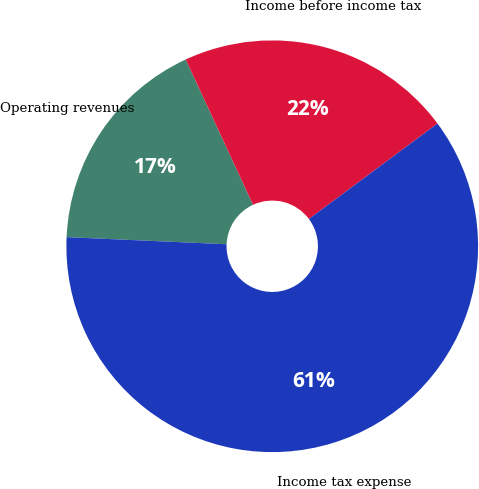Convert chart to OTSL. <chart><loc_0><loc_0><loc_500><loc_500><pie_chart><fcel>Operating revenues<fcel>Income before income tax<fcel>Income tax expense<nl><fcel>17.39%<fcel>21.74%<fcel>60.87%<nl></chart> 